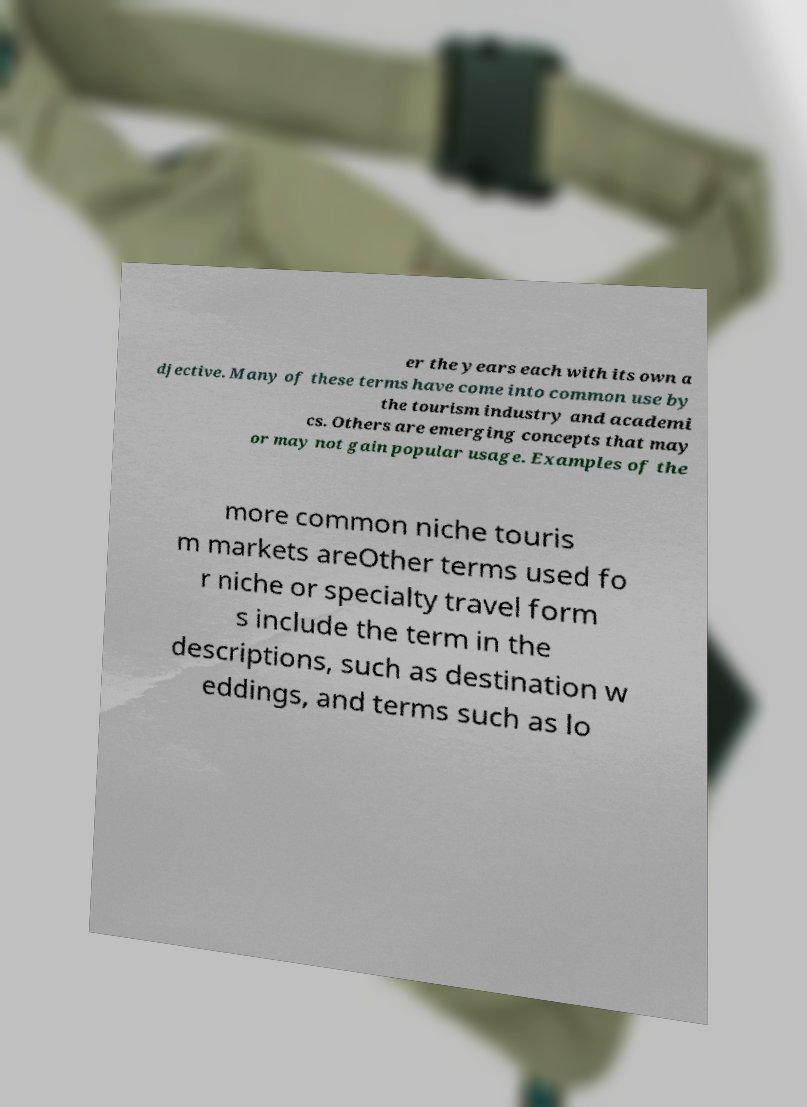For documentation purposes, I need the text within this image transcribed. Could you provide that? er the years each with its own a djective. Many of these terms have come into common use by the tourism industry and academi cs. Others are emerging concepts that may or may not gain popular usage. Examples of the more common niche touris m markets areOther terms used fo r niche or specialty travel form s include the term in the descriptions, such as destination w eddings, and terms such as lo 